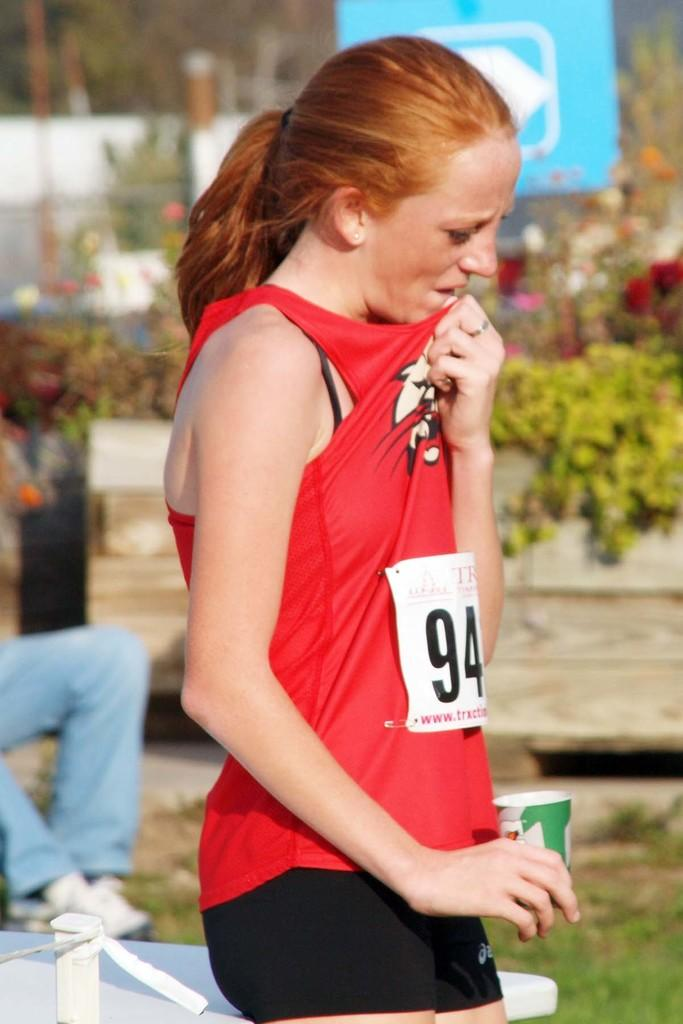Who is the main subject in the image? There is a woman in the image. What is the woman doing in the image? The woman is standing in the image. What is the woman holding in her hands? The woman is holding a disposable tumbler in her hands. What can be seen in the background of the image? There are plants and flowers in the background of the image. What type of insurance does the woman have in the image? There is no information about insurance in the image; it only shows a woman standing with a disposable tumbler and a background of plants and flowers. 